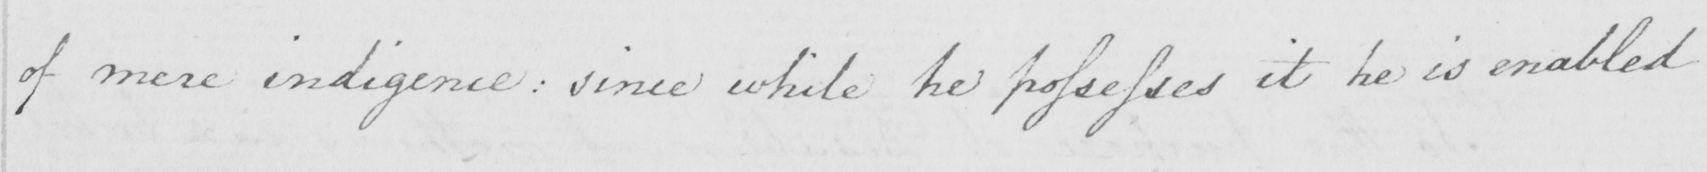Can you tell me what this handwritten text says? of mere indigence :  since while he possesses it he is enabled 